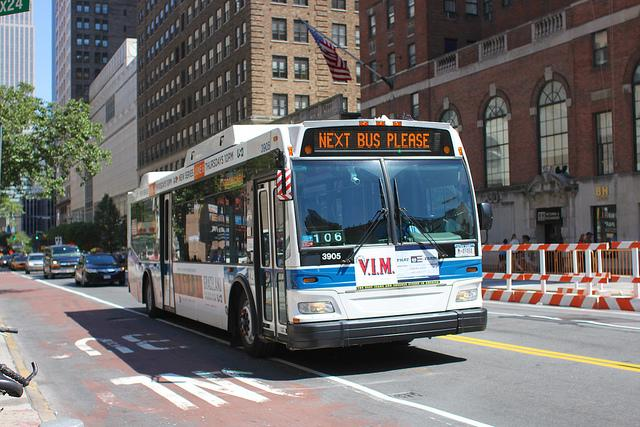Where does the bus go next? Please explain your reasoning. bus terminal. The bus is headed to the bus terminal since the sign says to take the next bus. 